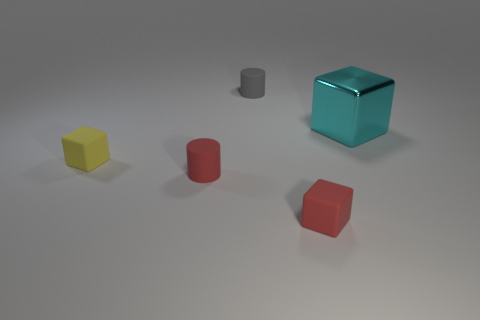Are there any other things that have the same size as the metal block?
Offer a very short reply. No. How many other things are there of the same shape as the big shiny thing?
Your response must be concise. 2. There is a rubber cylinder that is behind the cyan metallic block; is there a yellow object that is behind it?
Your answer should be very brief. No. What number of tiny cyan rubber cylinders are there?
Your answer should be very brief. 0. There is a shiny block; does it have the same color as the small rubber block that is behind the red rubber cube?
Give a very brief answer. No. Is the number of tiny gray objects greater than the number of red matte objects?
Ensure brevity in your answer.  No. Is there anything else that has the same color as the metal thing?
Your answer should be very brief. No. What number of other things are the same size as the red cube?
Make the answer very short. 3. What is the material of the small cube that is in front of the matte block on the left side of the tiny cube that is in front of the red matte cylinder?
Your answer should be very brief. Rubber. Do the cyan block and the tiny block left of the tiny red rubber cube have the same material?
Your response must be concise. No. 